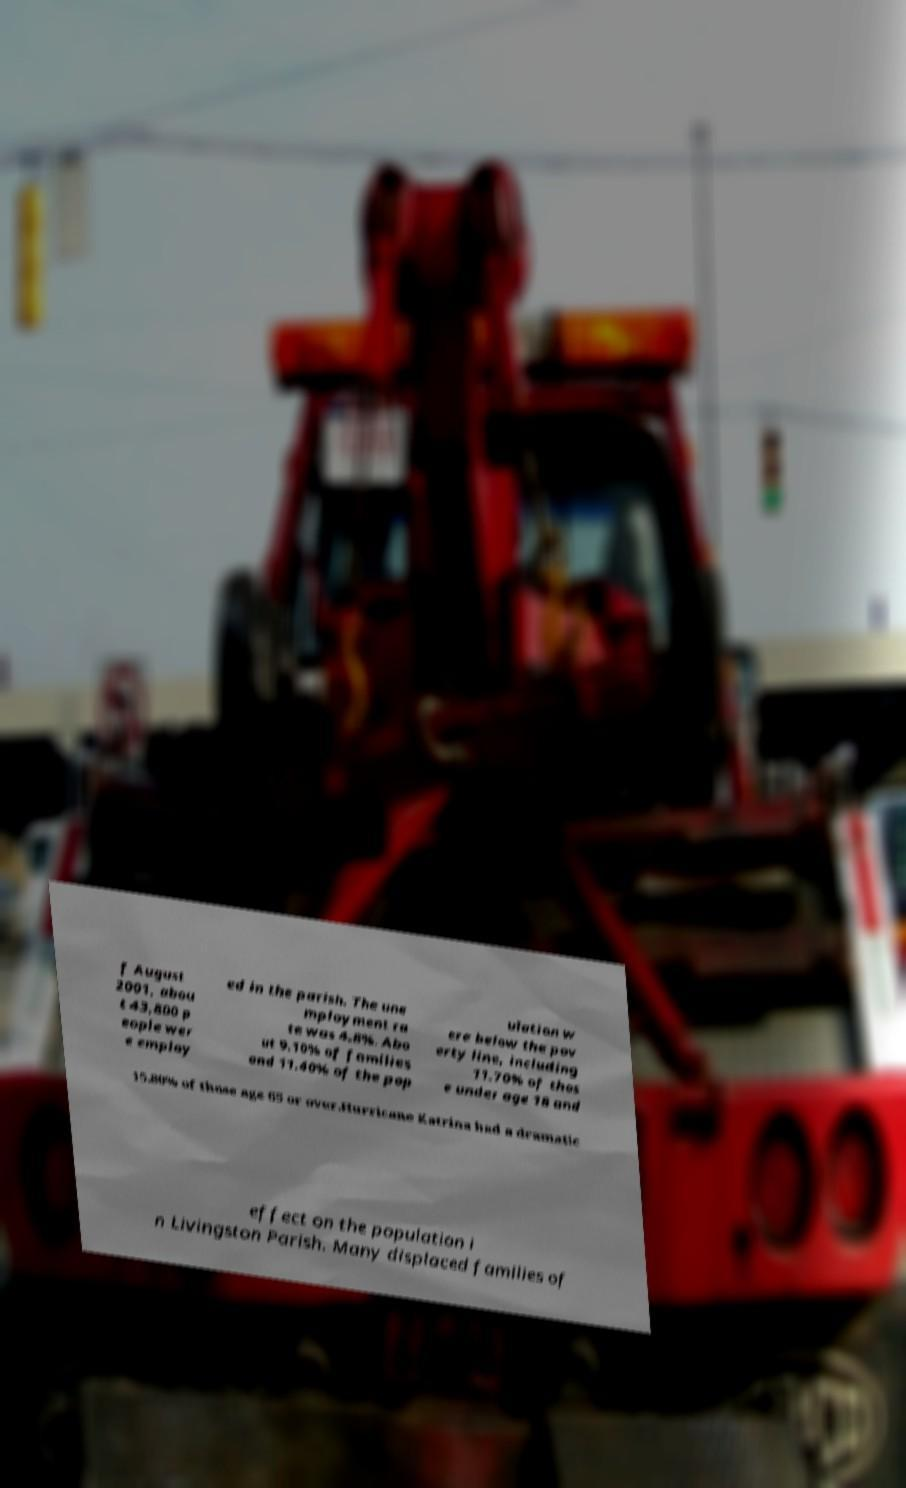I need the written content from this picture converted into text. Can you do that? f August 2001, abou t 43,800 p eople wer e employ ed in the parish. The une mployment ra te was 4.8%. Abo ut 9.10% of families and 11.40% of the pop ulation w ere below the pov erty line, including 11.70% of thos e under age 18 and 15.80% of those age 65 or over.Hurricane Katrina had a dramatic effect on the population i n Livingston Parish. Many displaced families of 